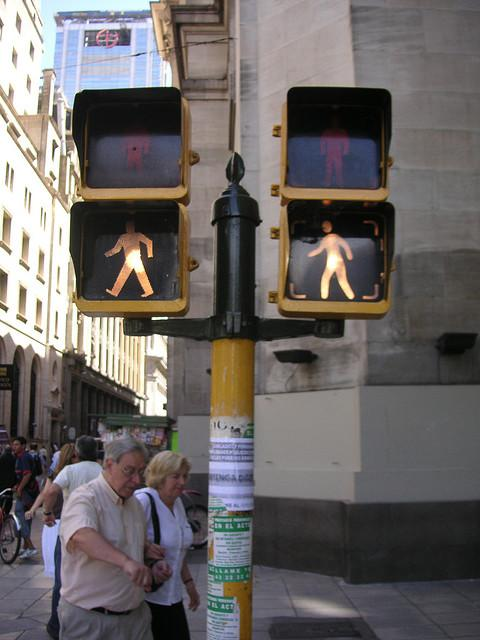What is the traffic light permitting?

Choices:
A) jaywalking
B) parking
C) crossing
D) driving crossing 